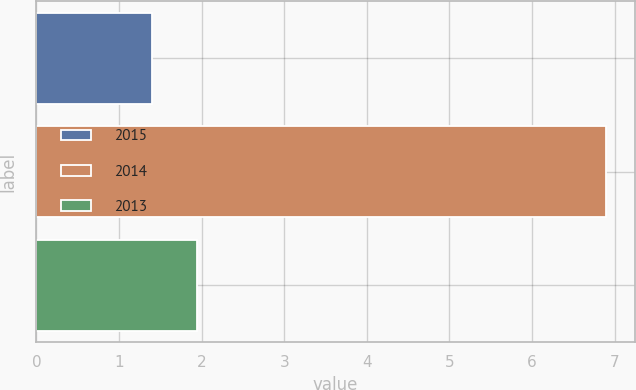Convert chart to OTSL. <chart><loc_0><loc_0><loc_500><loc_500><bar_chart><fcel>2015<fcel>2014<fcel>2013<nl><fcel>1.4<fcel>6.9<fcel>1.95<nl></chart> 